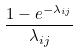<formula> <loc_0><loc_0><loc_500><loc_500>\frac { 1 - e ^ { - \lambda _ { i j } } } { \lambda _ { i j } }</formula> 